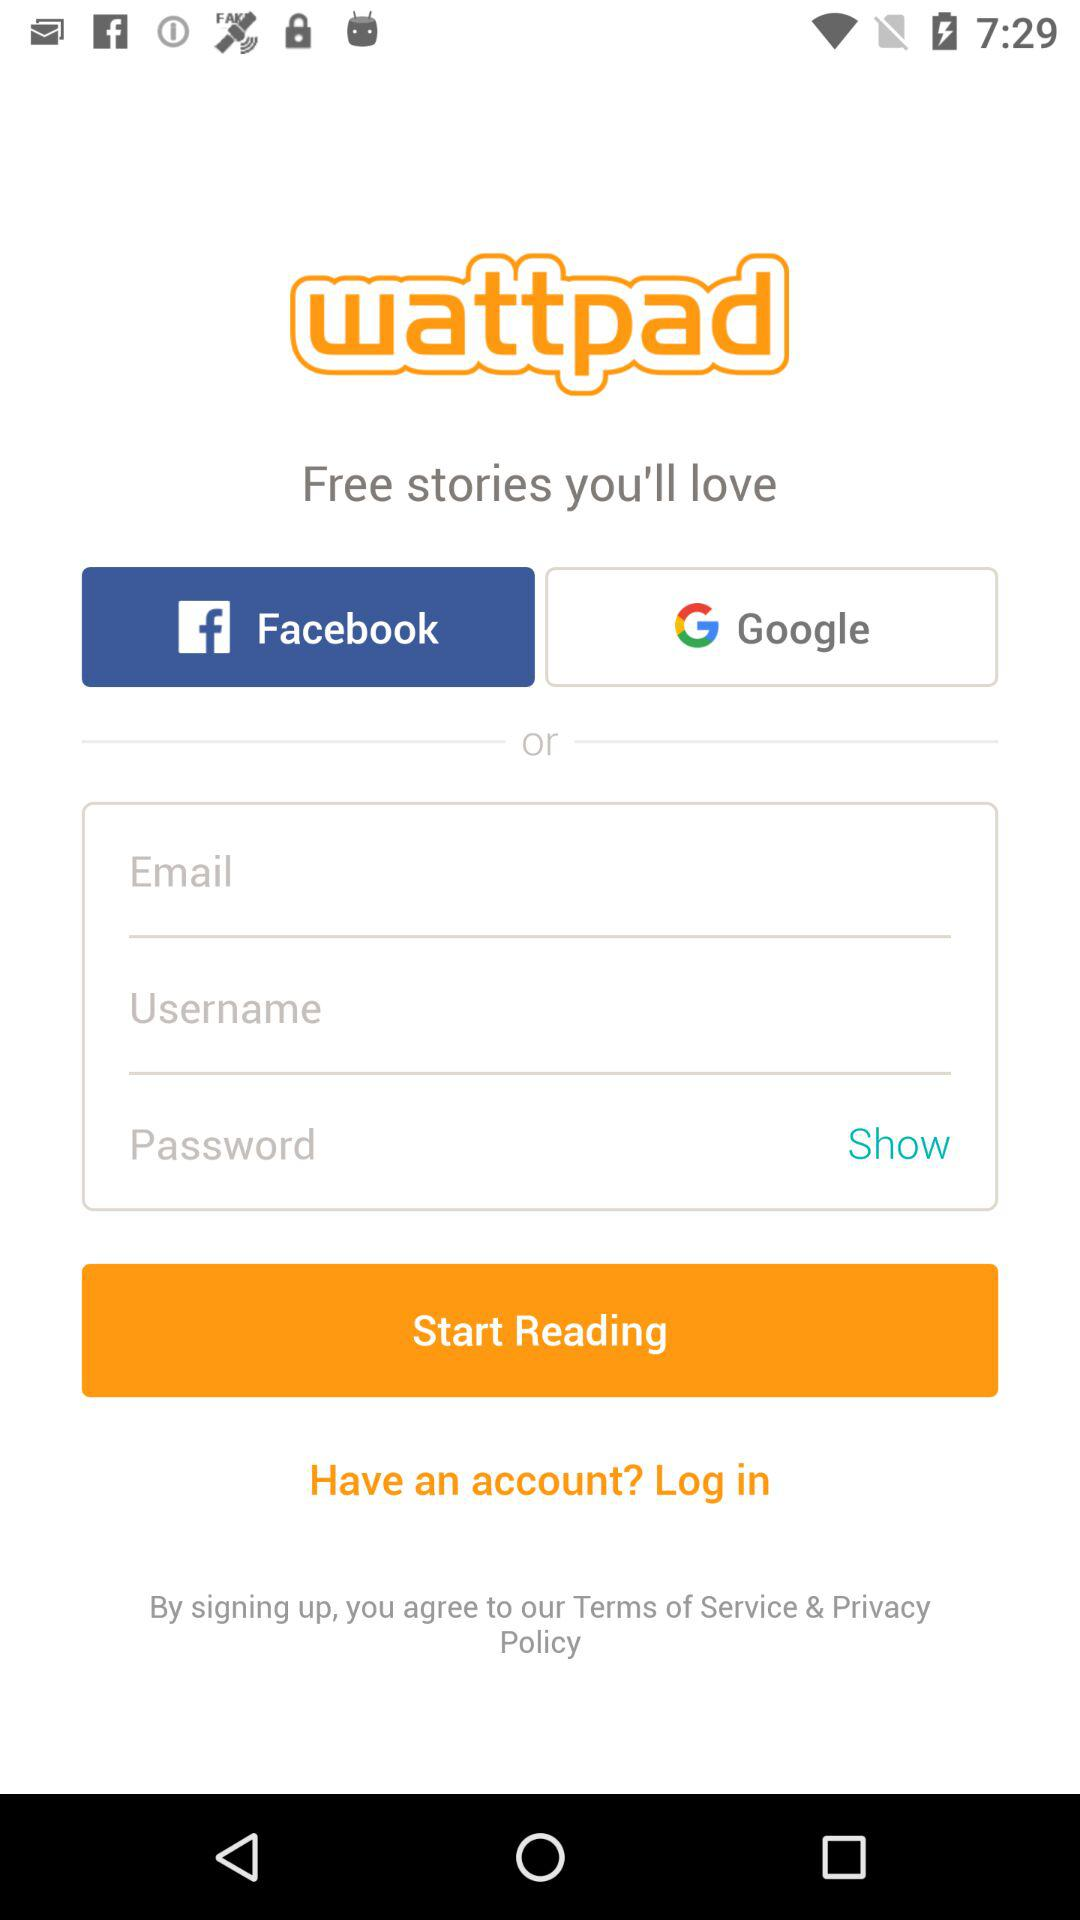How many text inputs are there for the login form?
Answer the question using a single word or phrase. 3 